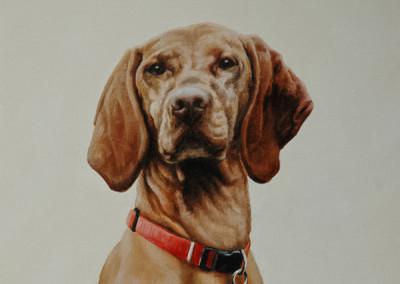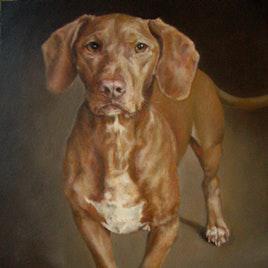The first image is the image on the left, the second image is the image on the right. Assess this claim about the two images: "The left image features a dog with its head turned to the left, and the right image features a dog sitting upright, gazing straight ahead, and wearing a collar with a tag dangling from it.". Correct or not? Answer yes or no. No. The first image is the image on the left, the second image is the image on the right. For the images shown, is this caption "The dog on the left is looking left and the dog on the right is looking straight ahead." true? Answer yes or no. No. 